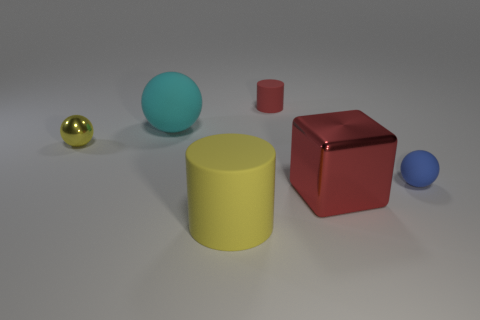What might be the function of these objects if they were placed in a real-world setting? In a real-world context, these objects could serve various purposes. The balls may be decorative elements or toys, the cylinders could be storage containers or pedestals, and the cube might be a piece of furniture or a decorative block. Their uses would largely depend on the materials they're made of and their sizes relative to their environment. 